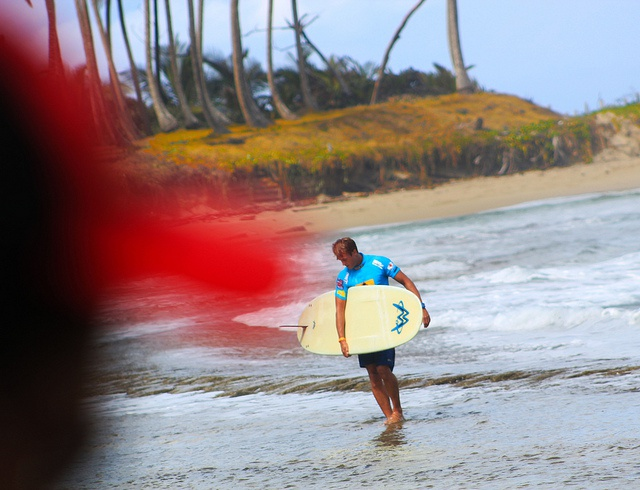Describe the objects in this image and their specific colors. I can see people in violet, black, maroon, red, and brown tones, surfboard in violet, khaki, beige, darkgray, and black tones, and people in violet, maroon, black, and lightblue tones in this image. 